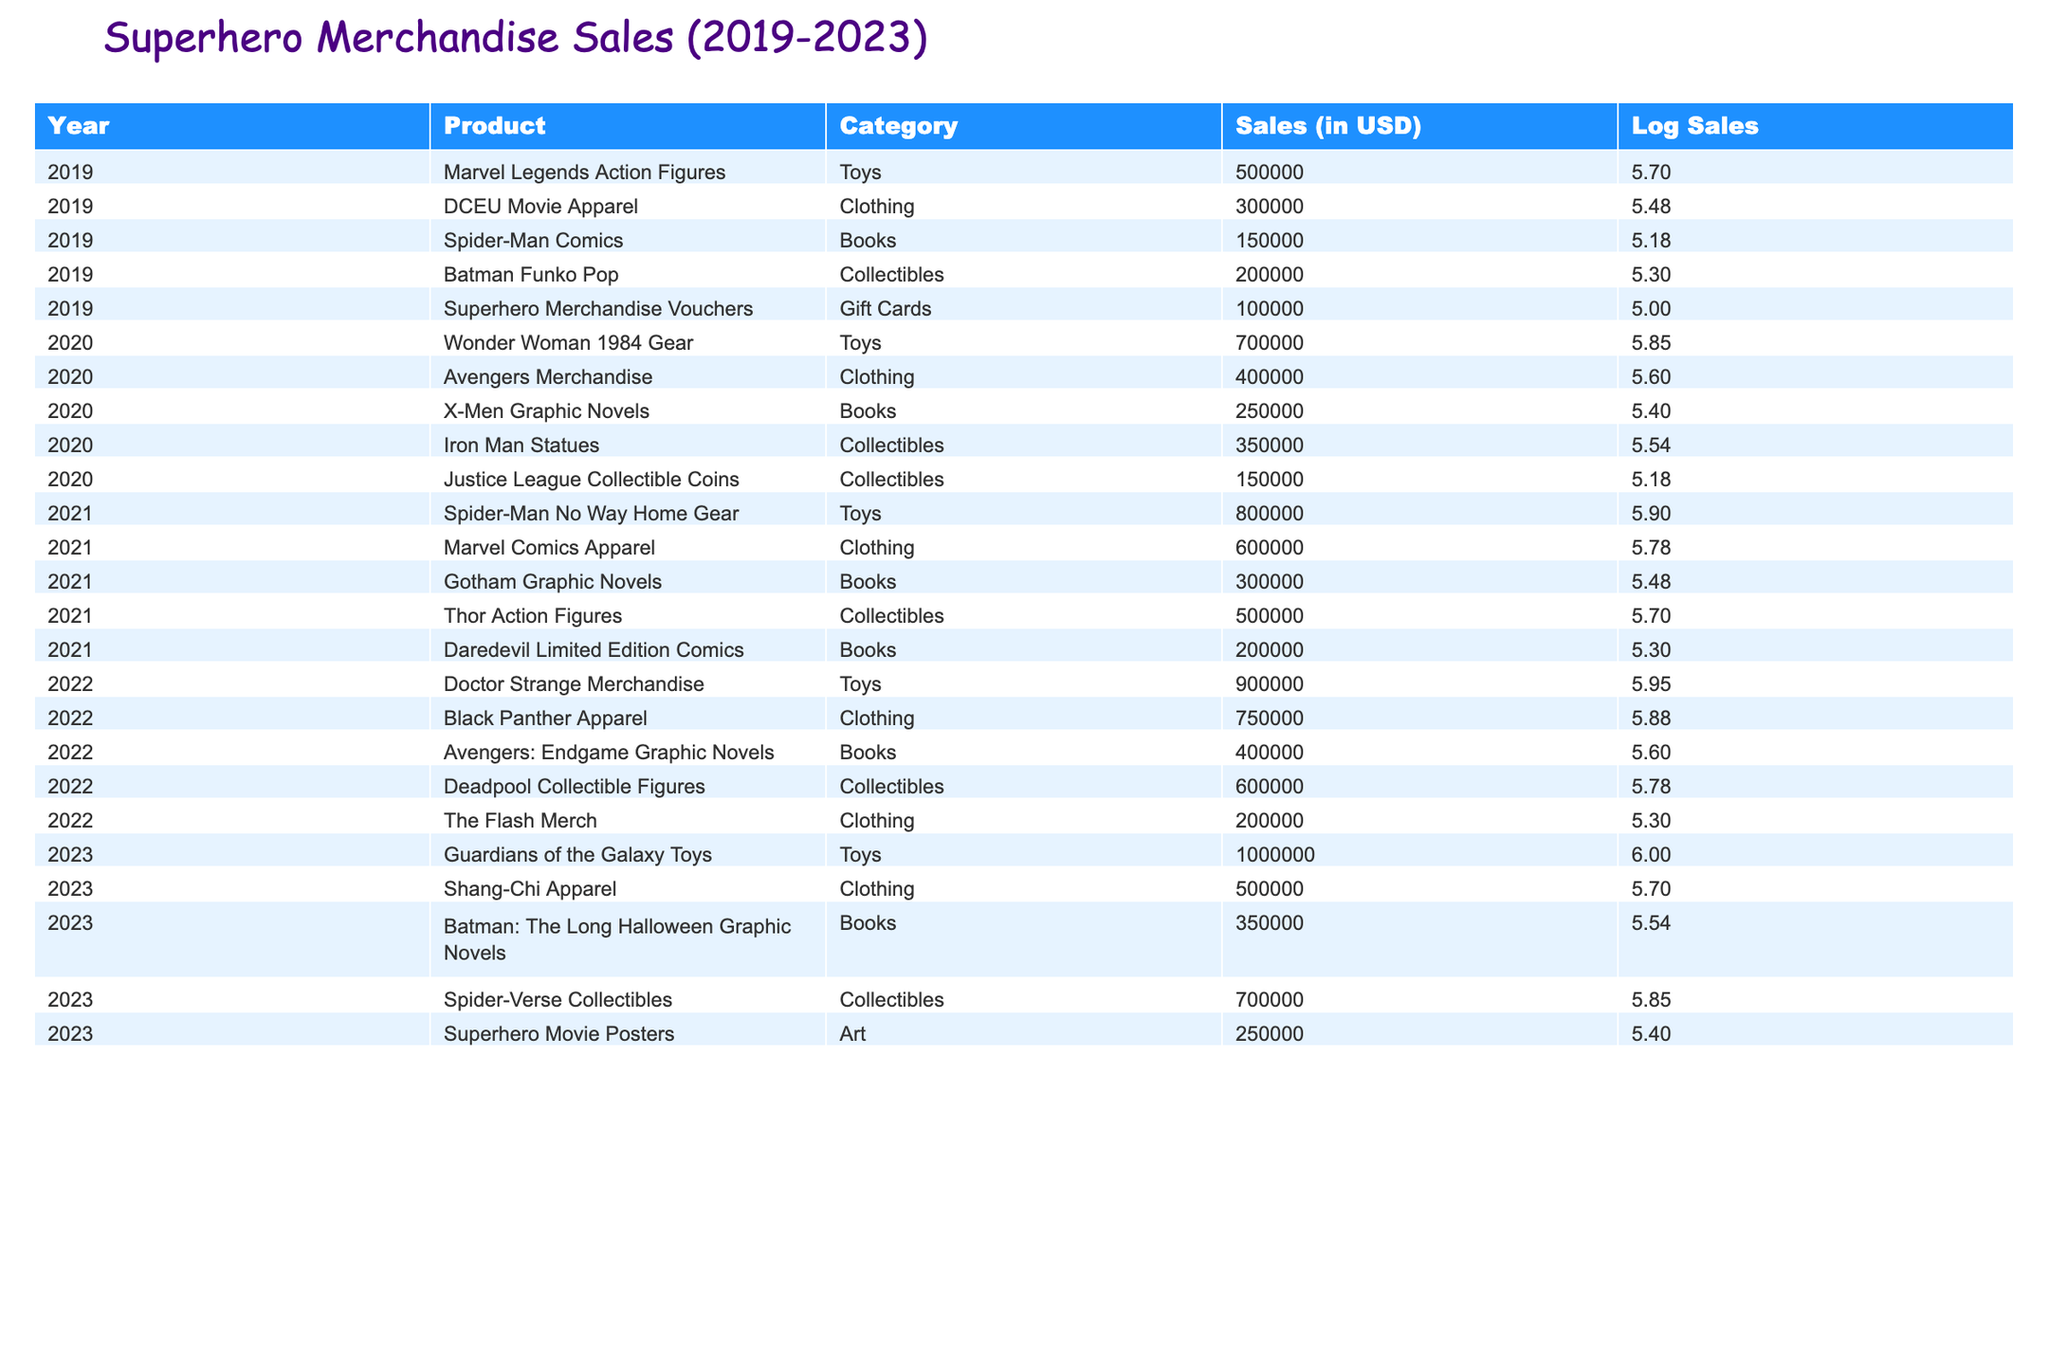What is the highest-selling item in 2022? In 2022, the highest-selling item is "Doctor Strange Merchandise" with sales of 900,000 USD. This can be identified by comparing the sales figures across all products in that year.
Answer: 900,000 USD What were the total sales of "Toys" from 2019 to 2023? The total sales of "Toys" can be summed from each year: 500,000 (2019) + 700,000 (2020) + 800,000 (2021) + 900,000 (2022) + 1,000,000 (2023) = 3,900,000 USD. Adding these figures gives the total sales over the five-year period.
Answer: 3,900,000 USD Did the sales of "Clothing" increase every year from 2019 to 2023? To determine if sales increased every year, we look at the figures: 300,000 (2019), 400,000 (2020), 600,000 (2021), 750,000 (2022), and 500,000 (2023). The sales decreased from 750,000 in 2022 to 500,000 in 2023, so the answer is no.
Answer: No What is the average sales figure for "Books" over the five years? The sales for Books are: 150,000 (2019), 250,000 (2020), 300,000 (2021), 400,000 (2022), and 350,000 (2023). Summing these values: 150,000 + 250,000 + 300,000 + 400,000 + 350,000 = 1,450,000 USD. Dividing by the number of years (5) gives an average of 290,000 USD.
Answer: 290,000 USD Which year had the largest contribution to "Collectibles" sales? The sales for Collectibles per year are as follows: 200,000 (2019), 350,000 (2020), 500,000 (2021), 600,000 (2022), and 700,000 (2023). The largest contribution came from 2023, with sales of 700,000 USD. This can be determined by comparing the sales figures for Collectibles across each year.
Answer: 2023 What was the increase in sales from "Marvel Legends Action Figures" in 2019 to "Guardians of the Galaxy Toys" in 2023? The sales figures are 500,000 USD for "Marvel Legends Action Figures" in 2019 and 1,000,000 USD for "Guardians of the Galaxy Toys" in 2023. The increase can be calculated as 1,000,000 - 500,000 = 500,000 USD.
Answer: 500,000 USD Did "Spider-Man" merchandise have higher sales in 2021 than in 2019? The sales figures are 150,000 USD for Spider-Man Comics in 2019 and 800,000 USD for Spider-Man No Way Home Gear in 2021. Since 800,000 is greater than 150,000, the answer is yes.
Answer: Yes What was the total sales of "Gift Cards" across all years? The only sales for Gift Cards occurred in 2019 with 100,000 USD. Since there are no additional years reporting sales for this category, the total remains 100,000 USD.
Answer: 100,000 USD 